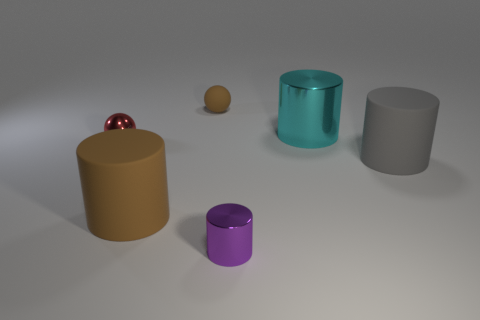Subtract 1 cylinders. How many cylinders are left? 3 Add 1 small shiny things. How many objects exist? 7 Subtract all cylinders. How many objects are left? 2 Add 3 small rubber spheres. How many small rubber spheres exist? 4 Subtract 1 red spheres. How many objects are left? 5 Subtract all cyan metal cylinders. Subtract all purple things. How many objects are left? 4 Add 2 brown spheres. How many brown spheres are left? 3 